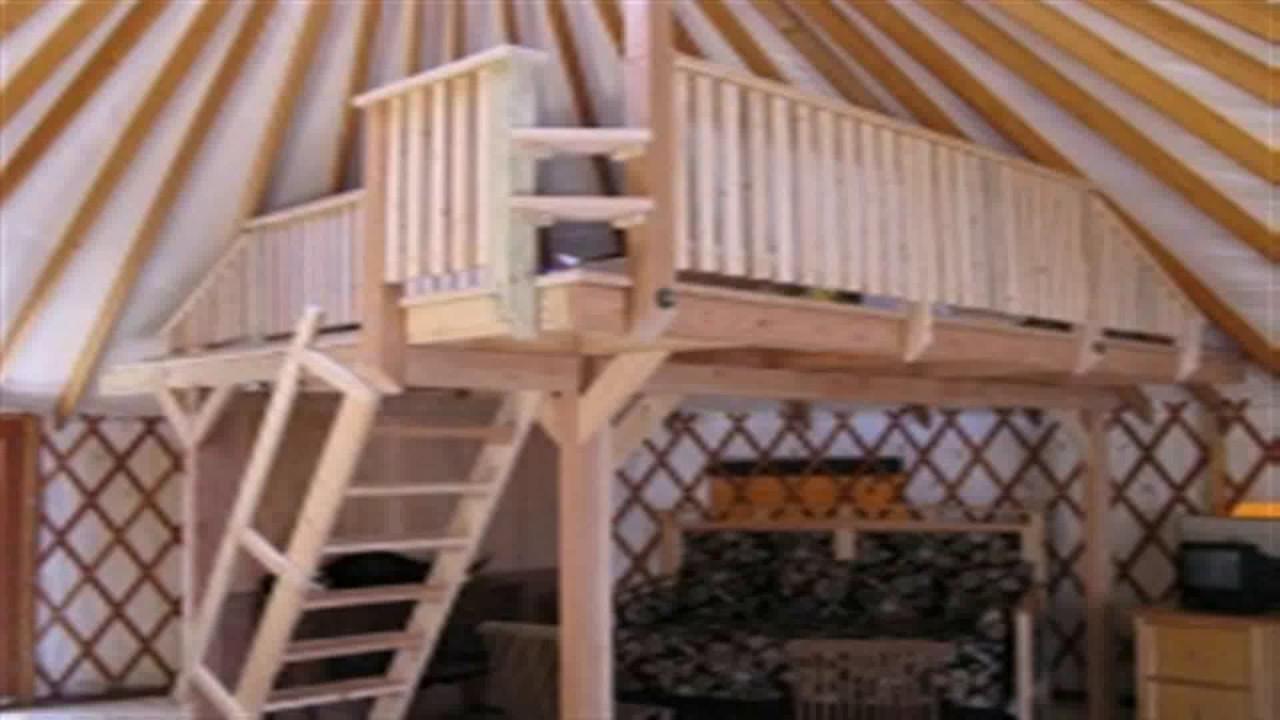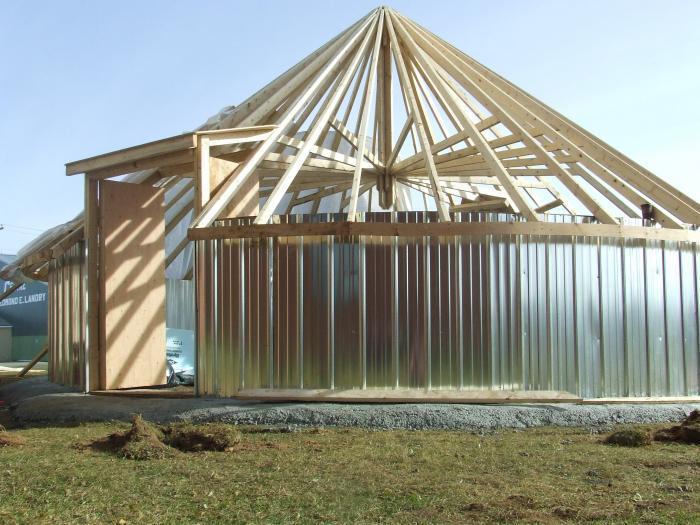The first image is the image on the left, the second image is the image on the right. Evaluate the accuracy of this statement regarding the images: "One of the images is showing the hut from the outside.". Is it true? Answer yes or no. Yes. The first image is the image on the left, the second image is the image on the right. Examine the images to the left and right. Is the description "An image shows the exterior framework of an unfinished building with a cone-shaped roof." accurate? Answer yes or no. Yes. 